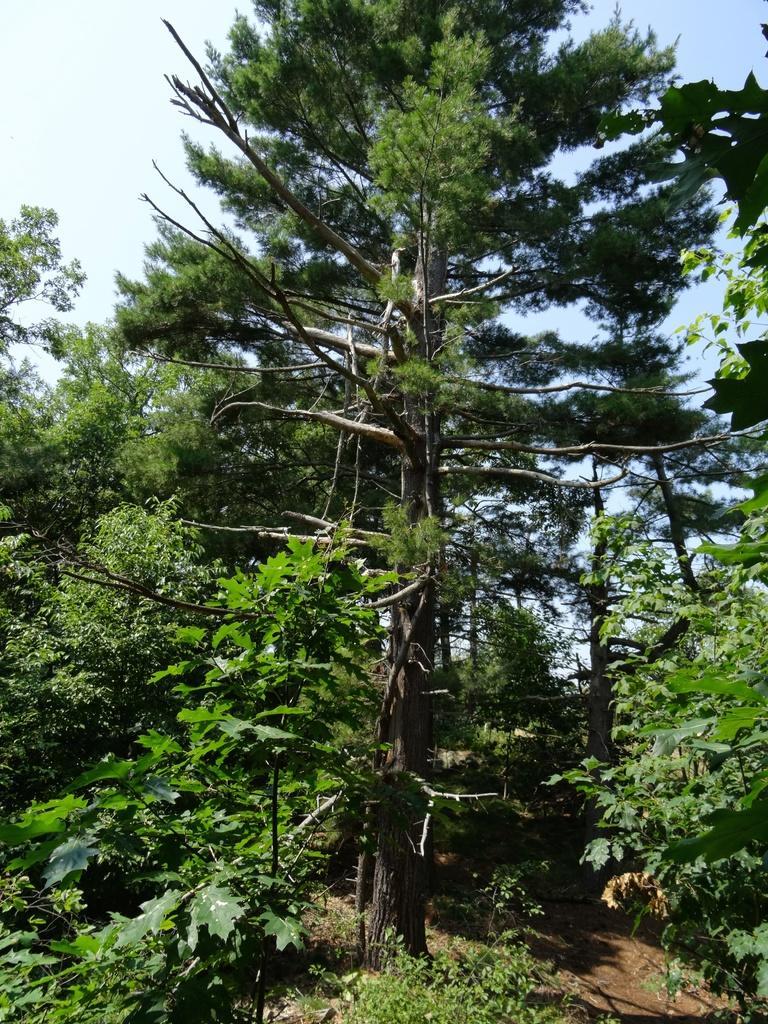Could you give a brief overview of what you see in this image? In this image I can see few trees in green color. In the background the sky is in blue and white color. 